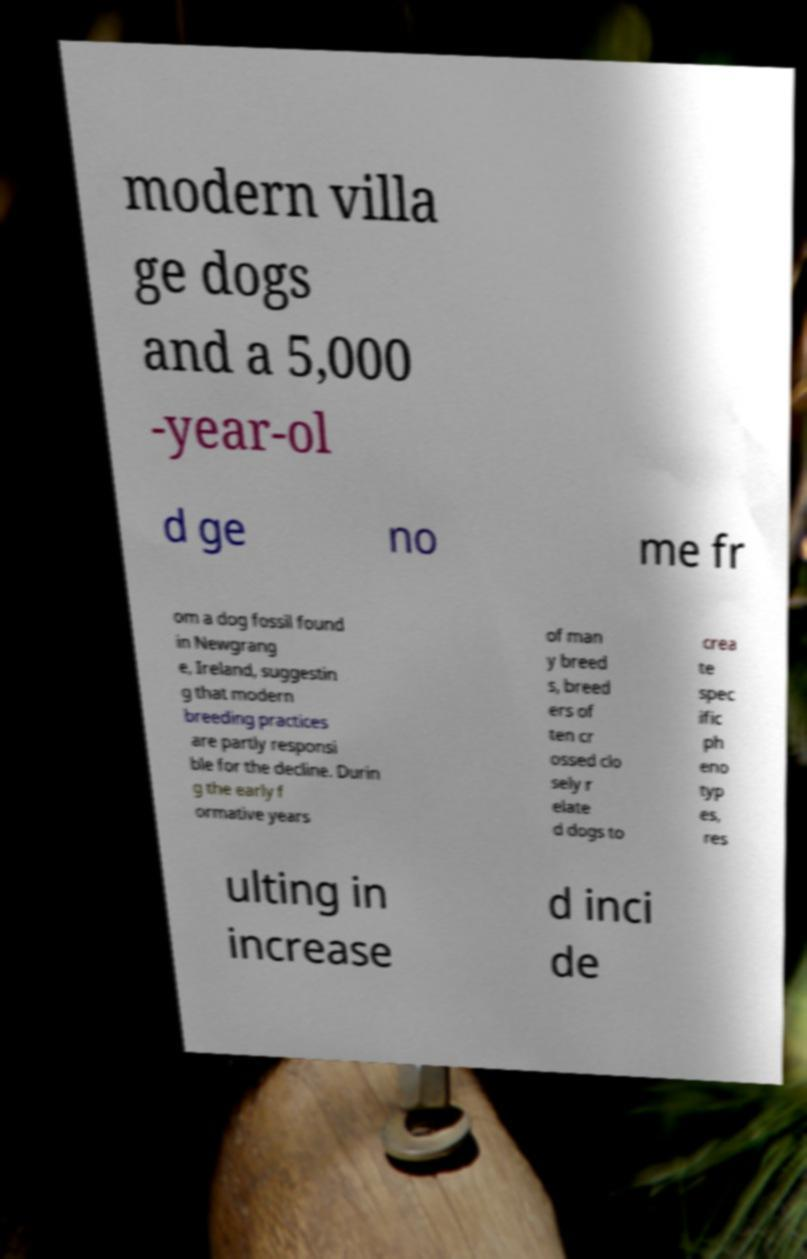For documentation purposes, I need the text within this image transcribed. Could you provide that? modern villa ge dogs and a 5,000 -year-ol d ge no me fr om a dog fossil found in Newgrang e, Ireland, suggestin g that modern breeding practices are partly responsi ble for the decline. Durin g the early f ormative years of man y breed s, breed ers of ten cr ossed clo sely r elate d dogs to crea te spec ific ph eno typ es, res ulting in increase d inci de 